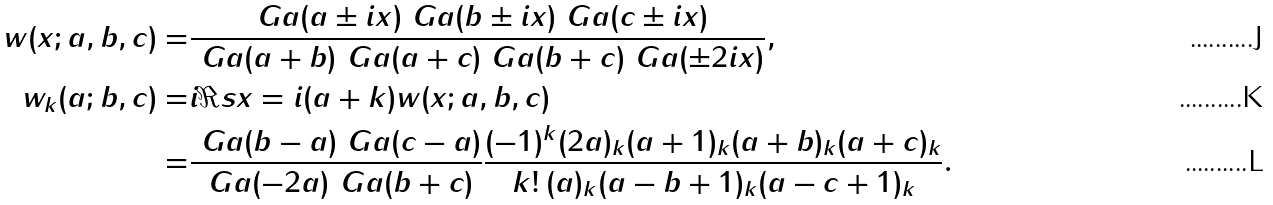<formula> <loc_0><loc_0><loc_500><loc_500>w ( x ; a , b , c ) = & \frac { \ G a ( a \pm i x ) \ G a ( b \pm i x ) \ G a ( c \pm i x ) } { \ G a ( a + b ) \ G a ( a + c ) \ G a ( b + c ) \ G a ( \pm 2 i x ) } , \\ w _ { k } ( a ; b , c ) = & i \Re s { x = i ( a + k ) } w ( x ; a , b , c ) \\ = & \frac { \ G a ( b - a ) \ G a ( c - a ) } { \ G a ( - 2 a ) \ G a ( b + c ) } \frac { ( - 1 ) ^ { k } ( 2 a ) _ { k } ( a + 1 ) _ { k } ( a + b ) _ { k } ( a + c ) _ { k } } { k ! \, ( a ) _ { k } ( a - b + 1 ) _ { k } ( a - c + 1 ) _ { k } } .</formula> 